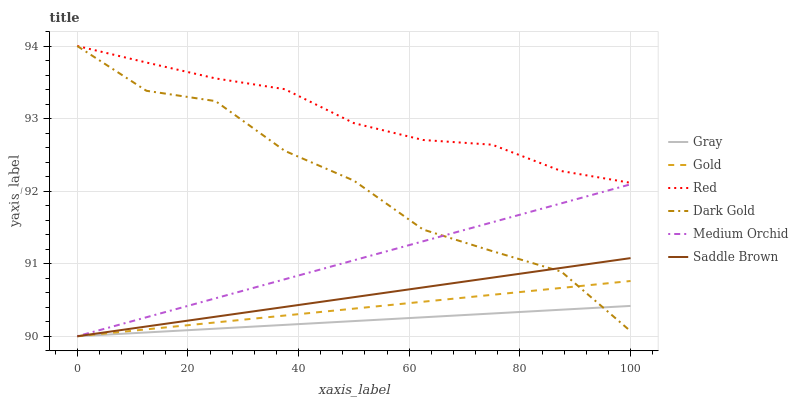Does Gray have the minimum area under the curve?
Answer yes or no. Yes. Does Red have the maximum area under the curve?
Answer yes or no. Yes. Does Gold have the minimum area under the curve?
Answer yes or no. No. Does Gold have the maximum area under the curve?
Answer yes or no. No. Is Saddle Brown the smoothest?
Answer yes or no. Yes. Is Dark Gold the roughest?
Answer yes or no. Yes. Is Gold the smoothest?
Answer yes or no. No. Is Gold the roughest?
Answer yes or no. No. Does Gray have the lowest value?
Answer yes or no. Yes. Does Dark Gold have the lowest value?
Answer yes or no. No. Does Red have the highest value?
Answer yes or no. Yes. Does Gold have the highest value?
Answer yes or no. No. Is Saddle Brown less than Red?
Answer yes or no. Yes. Is Red greater than Gray?
Answer yes or no. Yes. Does Gray intersect Saddle Brown?
Answer yes or no. Yes. Is Gray less than Saddle Brown?
Answer yes or no. No. Is Gray greater than Saddle Brown?
Answer yes or no. No. Does Saddle Brown intersect Red?
Answer yes or no. No. 